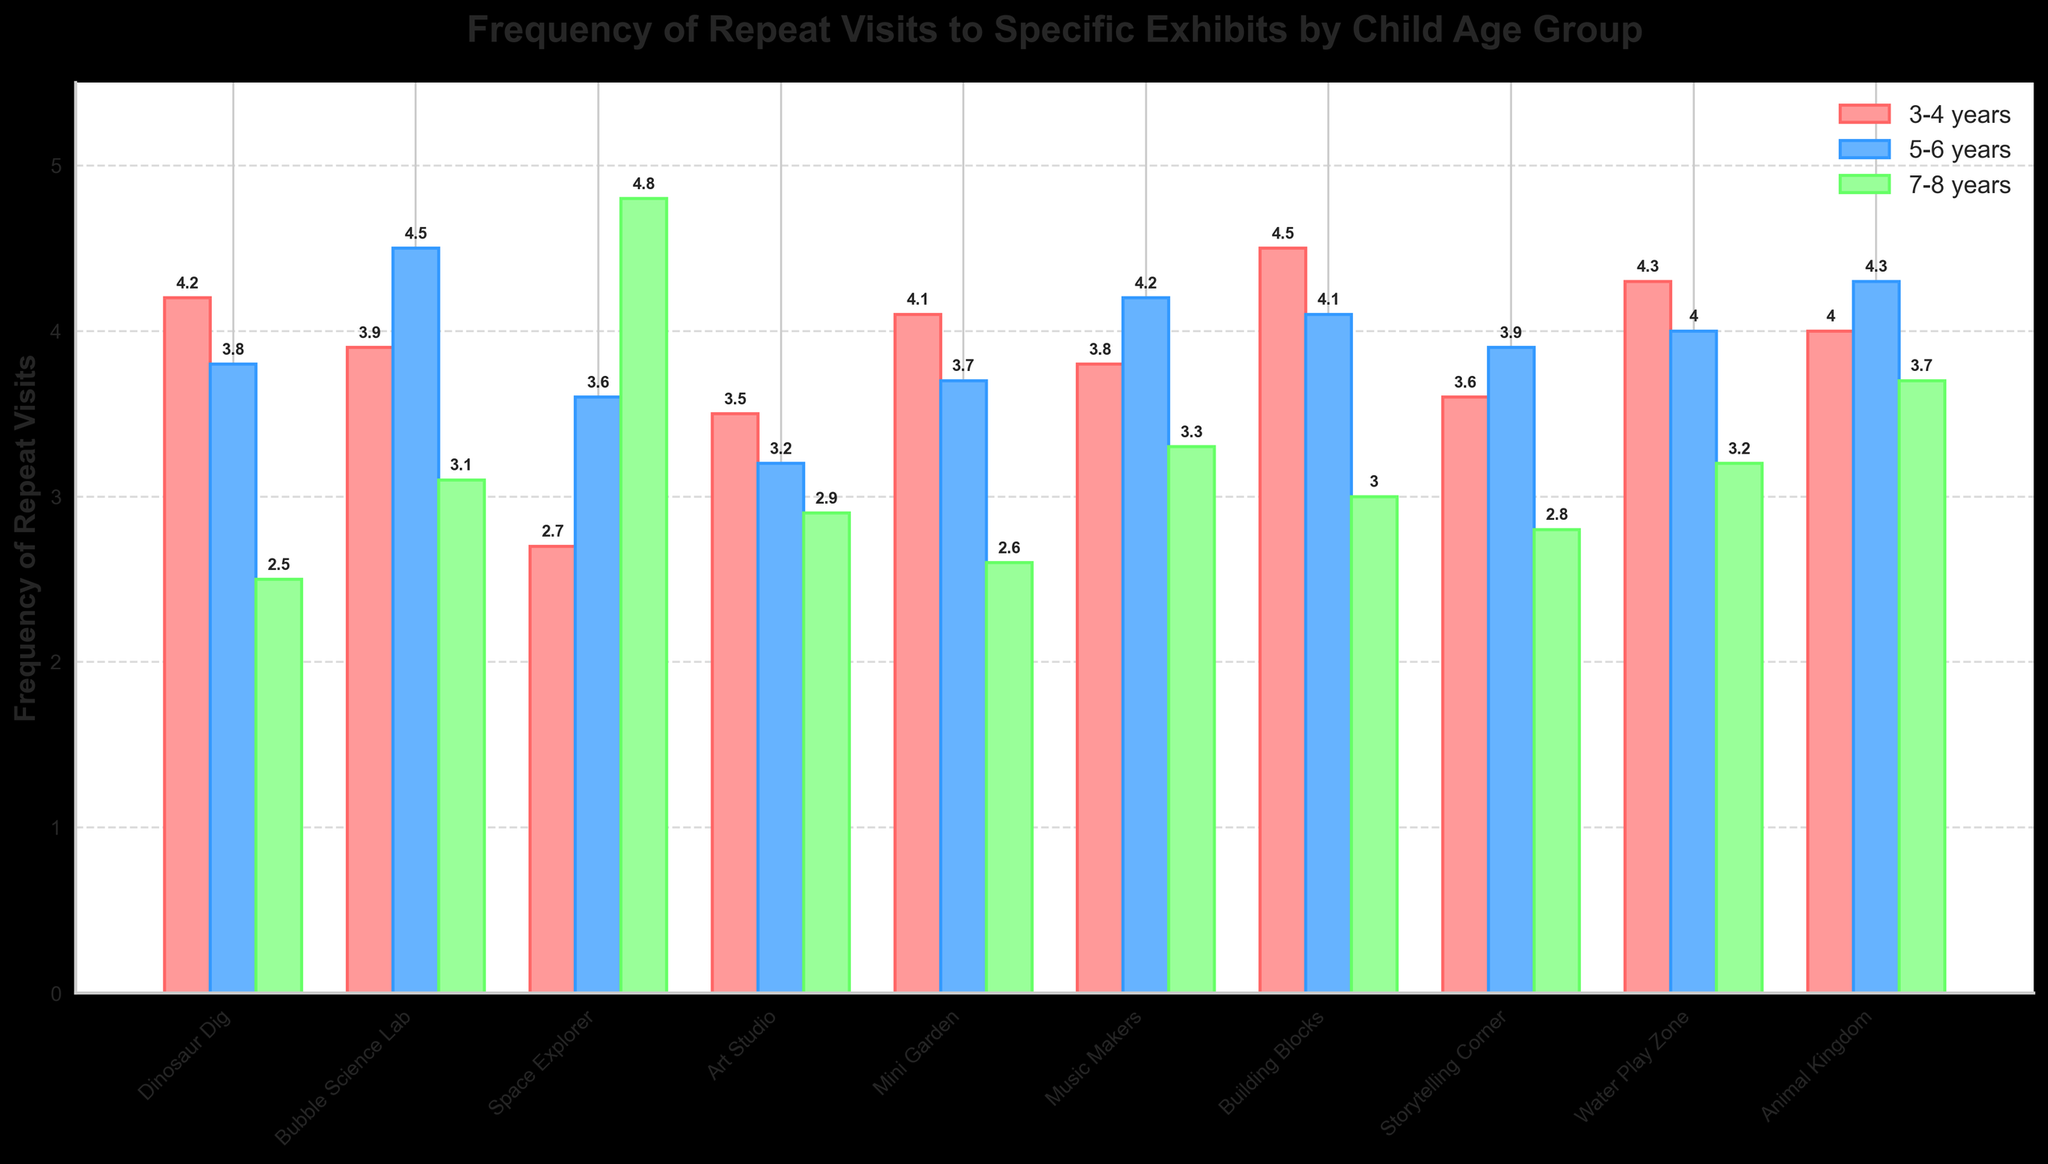Which exhibit has the highest frequency of repeat visits for the 3-4 years age group? To find the highest frequency of repeat visits for the 3-4 years age group, look at the bars corresponding to this age group and choose the tallest one. "Building Blocks" has the highest frequency with a value of 4.5.
Answer: Building Blocks Which age group visits "Space Explorer" the most frequently? To determine which age group visits "Space Explorer" the most frequently, compare the heights of the bars for "Space Explorer" across the three age groups. The 7-8 years age group has the highest bar with a frequency of 4.8.
Answer: 7-8 years What is the total frequency of repeat visits to the "Water Play Zone" for all age groups combined? Add up the frequencies for the 3-4 years (4.3), 5-6 years (4.0), and 7-8 years (3.2) age groups for the "Water Play Zone". The total is 4.3 + 4.0 + 3.2 = 11.5.
Answer: 11.5 Which exhibit is least visited by the 7-8 years age group? To find the least visited exhibit by the 7-8 years age group, locate the bar with the smallest height for this age group. "Dinosaur Dig" has the smallest bar with a frequency of 2.5.
Answer: Dinosaur Dig Which age group has the smallest average frequency of repeat visits across all exhibits? Calculate the average frequency of repeat visits for each age group by summing their frequencies across all exhibits and then dividing by the number of exhibits. For 3-4 years: (4.2 + 3.9 + 2.7 + 3.5 + 4.1 + 3.8 + 4.5 + 3.6 + 4.3 + 4.0) / 10 = 3.86. For 5-6 years: (3.8 + 4.5 + 3.6 + 3.2 + 3.7 + 4.2 + 4.1 + 3.9 + 4.0 + 4.3) / 10 = 3.93. For 7-8 years: (2.5 + 3.1 + 4.8 + 2.9 + 2.6 + 3.3 + 3.0 + 2.8 + 3.2 + 3.7) / 10 = 3.19. The 7-8 years age group has the smallest average frequency.
Answer: 7-8 years What is the difference in frequency of repeat visits between "Dinosaur Dig" and "Space Explorer" for the 5-6 years age group? Subtract the frequency of "Dinosaur Dig" (3.8) from the frequency of "Space Explorer" (3.6) for the 5-6 years age group. The difference is 3.6 - 3.8 = -0.2.
Answer: -0.2 Which exhibits have a frequency of repeat visits of 4 or higher for all age groups? Examine each exhibit to see if all three age groups have a frequency of 4 or higher. None of the exhibits meet this criterion as no exhibit has all bars with a height of 4 or higher.
Answer: None 